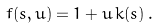Convert formula to latex. <formula><loc_0><loc_0><loc_500><loc_500>f ( s , u ) = 1 + u \, k ( s ) \, .</formula> 